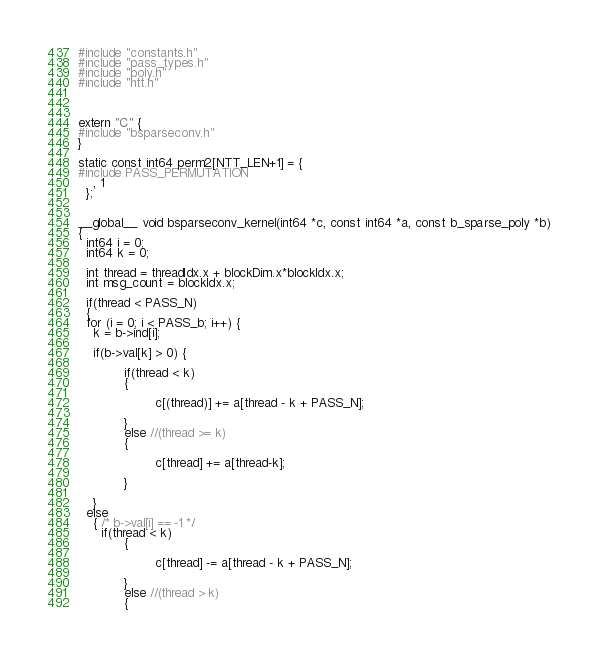Convert code to text. <code><loc_0><loc_0><loc_500><loc_500><_Cuda_>#include "constants.h"
#include "pass_types.h"
#include "poly.h"
#include "ntt.h"



extern "C" {
#include "bsparseconv.h"
}

static const int64 perm2[NTT_LEN+1] = {
#include PASS_PERMUTATION
    , 1
  };


__global__ void bsparseconv_kernel(int64 *c, const int64 *a, const b_sparse_poly *b)
{
  int64 i = 0;
  int64 k = 0;

  int thread = threadIdx.x + blockDim.x*blockIdx.x;
  int msg_count = blockIdx.x;

  if(thread < PASS_N)
  {
  for (i = 0; i < PASS_b; i++) {
    k = b->ind[i];

    if(b->val[k] > 0) {

    		if(thread < k)
    		{

    				c[(thread)] += a[thread - k + PASS_N];

    		}
    		else //(thread >= k)
    		{

    				c[thread] += a[thread-k];

    		}

    }
  else
    { /* b->val[i] == -1 */
	  if(thread < k)
	  		{

	  				c[thread] -= a[thread - k + PASS_N];

	  		}
	  		else //(thread > k)
	  		{
</code> 